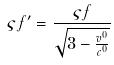<formula> <loc_0><loc_0><loc_500><loc_500>\varsigma f ^ { \prime } = \frac { \varsigma f } { \sqrt { 3 - \frac { v ^ { 0 } } { c ^ { 0 } } } }</formula> 